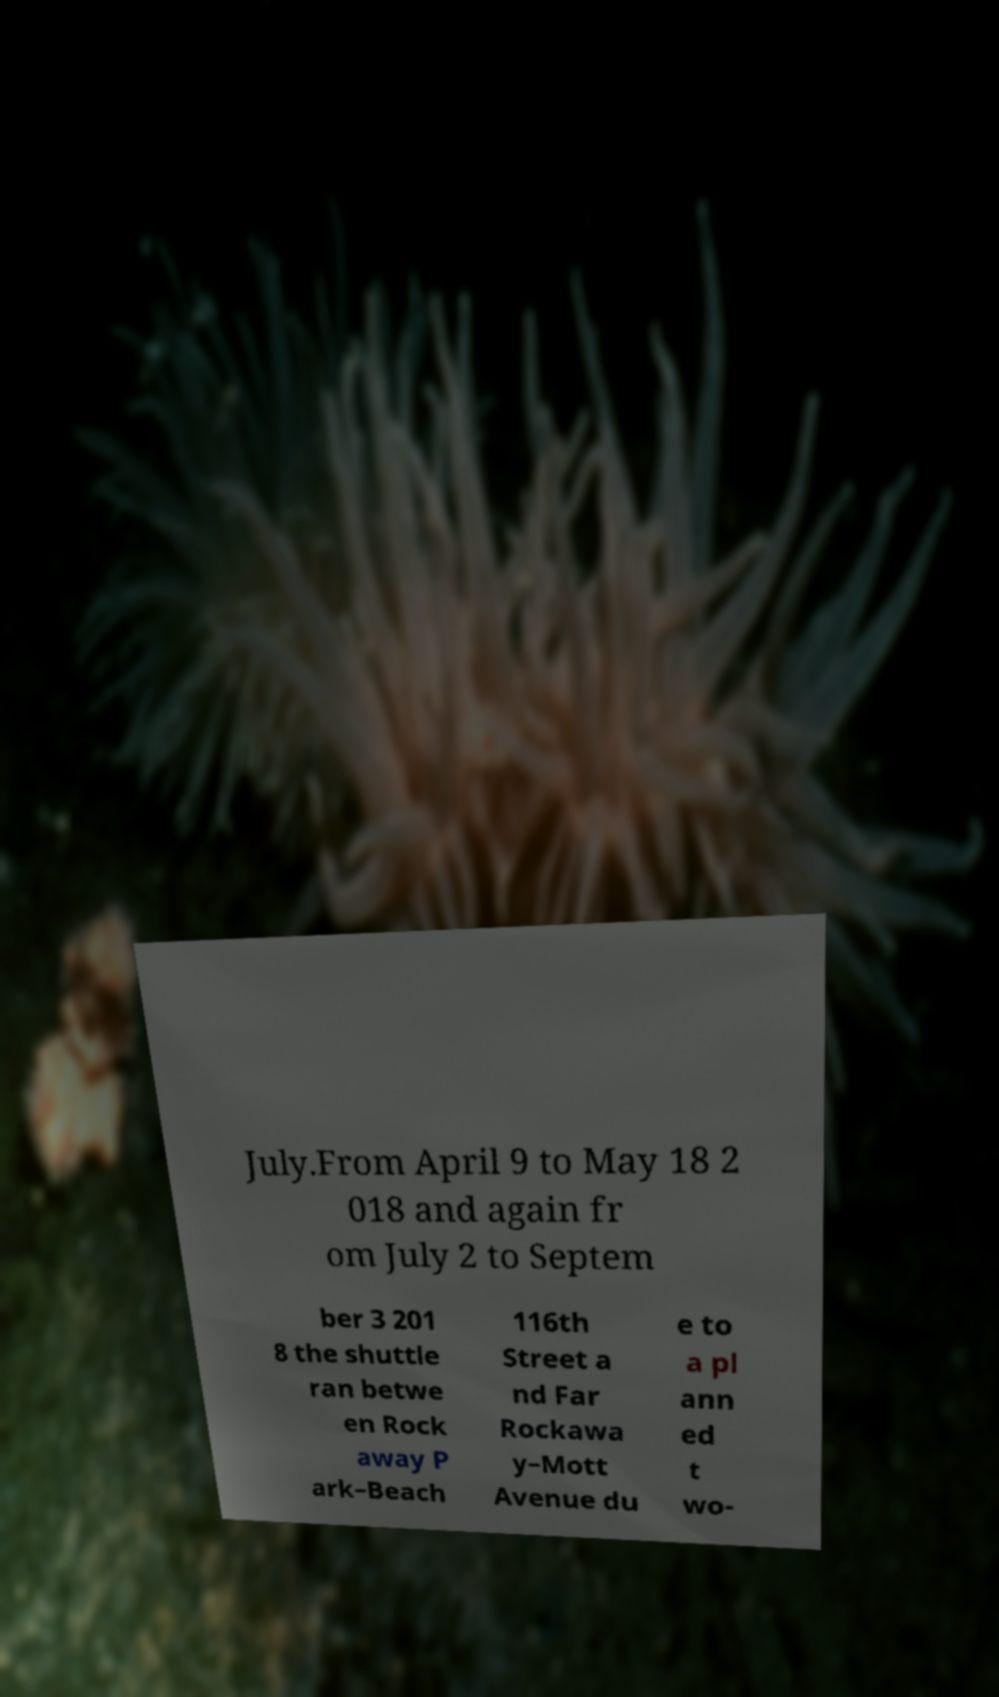Can you read and provide the text displayed in the image?This photo seems to have some interesting text. Can you extract and type it out for me? July.From April 9 to May 18 2 018 and again fr om July 2 to Septem ber 3 201 8 the shuttle ran betwe en Rock away P ark–Beach 116th Street a nd Far Rockawa y–Mott Avenue du e to a pl ann ed t wo- 